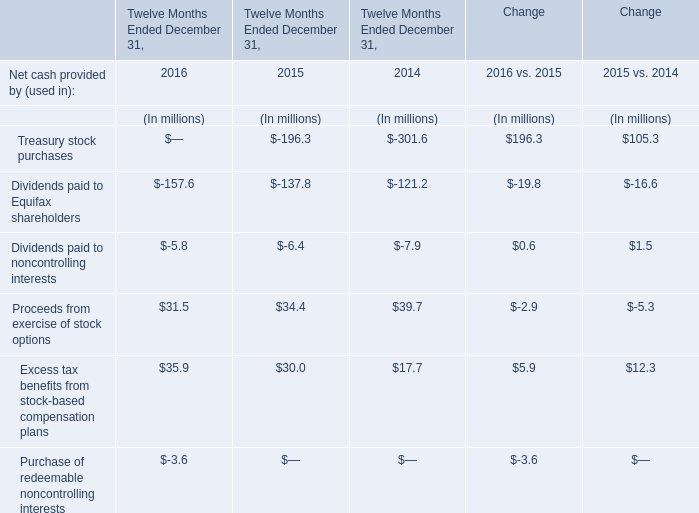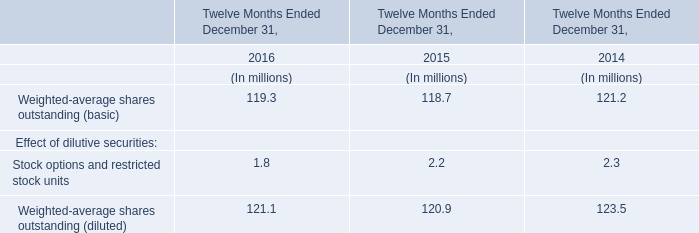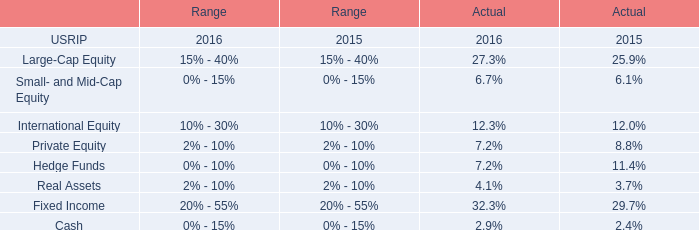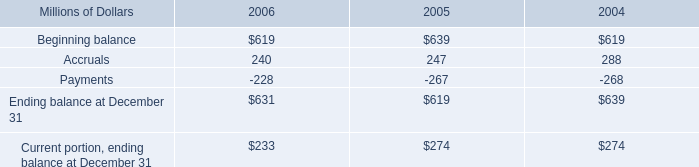In which year is Proceeds from exercise of stock options positive? 
Answer: 2014; 2015; 2016. 